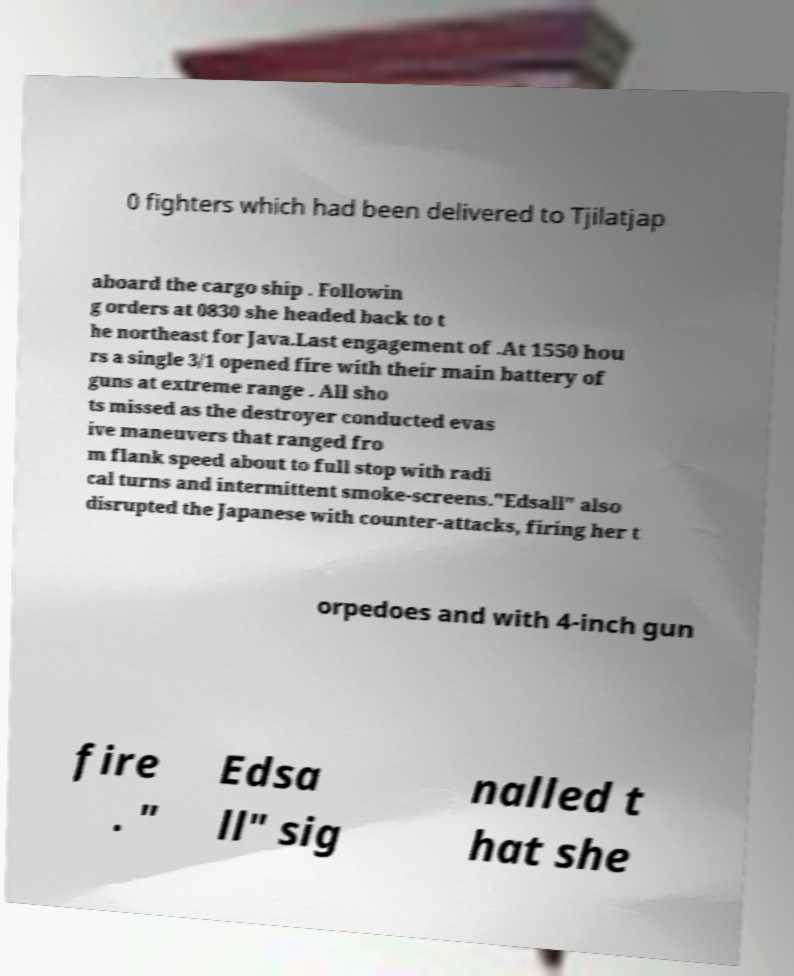Could you extract and type out the text from this image? 0 fighters which had been delivered to Tjilatjap aboard the cargo ship . Followin g orders at 0830 she headed back to t he northeast for Java.Last engagement of .At 1550 hou rs a single 3/1 opened fire with their main battery of guns at extreme range . All sho ts missed as the destroyer conducted evas ive maneuvers that ranged fro m flank speed about to full stop with radi cal turns and intermittent smoke-screens."Edsall" also disrupted the Japanese with counter-attacks, firing her t orpedoes and with 4-inch gun fire . " Edsa ll" sig nalled t hat she 